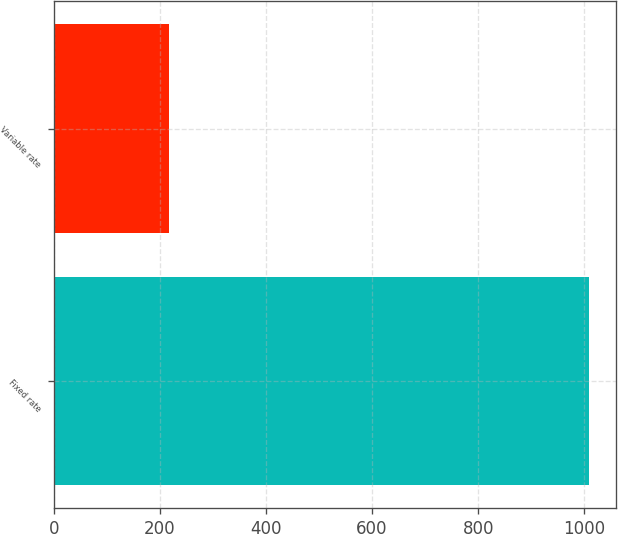Convert chart to OTSL. <chart><loc_0><loc_0><loc_500><loc_500><bar_chart><fcel>Fixed rate<fcel>Variable rate<nl><fcel>1009.5<fcel>217.9<nl></chart> 